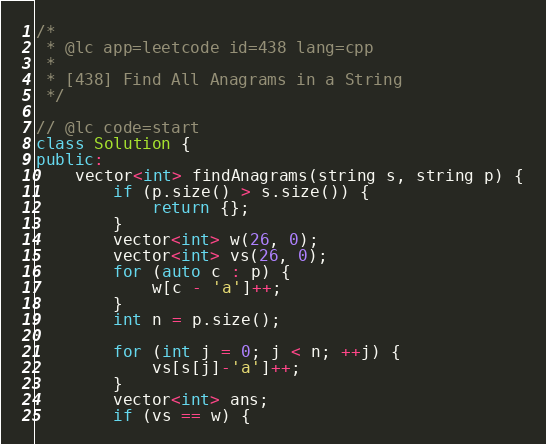<code> <loc_0><loc_0><loc_500><loc_500><_C++_>/*
 * @lc app=leetcode id=438 lang=cpp
 *
 * [438] Find All Anagrams in a String
 */

// @lc code=start
class Solution {
public:
    vector<int> findAnagrams(string s, string p) {
        if (p.size() > s.size()) {
            return {};
        }
        vector<int> w(26, 0);
        vector<int> vs(26, 0);
        for (auto c : p) {
            w[c - 'a']++;
        }
        int n = p.size();

        for (int j = 0; j < n; ++j) {
            vs[s[j]-'a']++;
        }
        vector<int> ans;
        if (vs == w) {</code> 